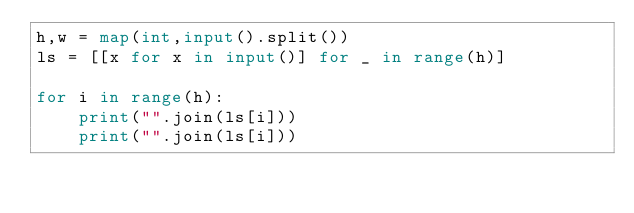<code> <loc_0><loc_0><loc_500><loc_500><_Python_>h,w = map(int,input().split())
ls = [[x for x in input()] for _ in range(h)]

for i in range(h):
    print("".join(ls[i]))
    print("".join(ls[i]))</code> 